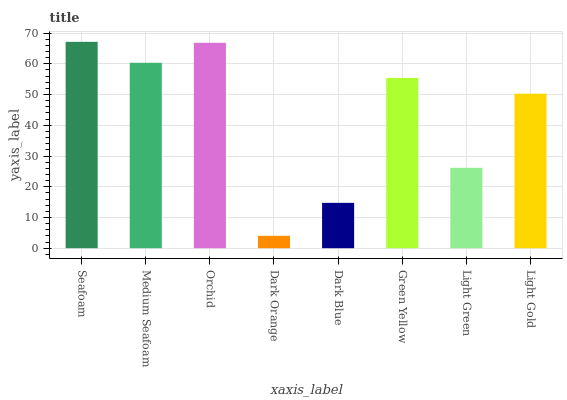Is Medium Seafoam the minimum?
Answer yes or no. No. Is Medium Seafoam the maximum?
Answer yes or no. No. Is Seafoam greater than Medium Seafoam?
Answer yes or no. Yes. Is Medium Seafoam less than Seafoam?
Answer yes or no. Yes. Is Medium Seafoam greater than Seafoam?
Answer yes or no. No. Is Seafoam less than Medium Seafoam?
Answer yes or no. No. Is Green Yellow the high median?
Answer yes or no. Yes. Is Light Gold the low median?
Answer yes or no. Yes. Is Dark Blue the high median?
Answer yes or no. No. Is Orchid the low median?
Answer yes or no. No. 